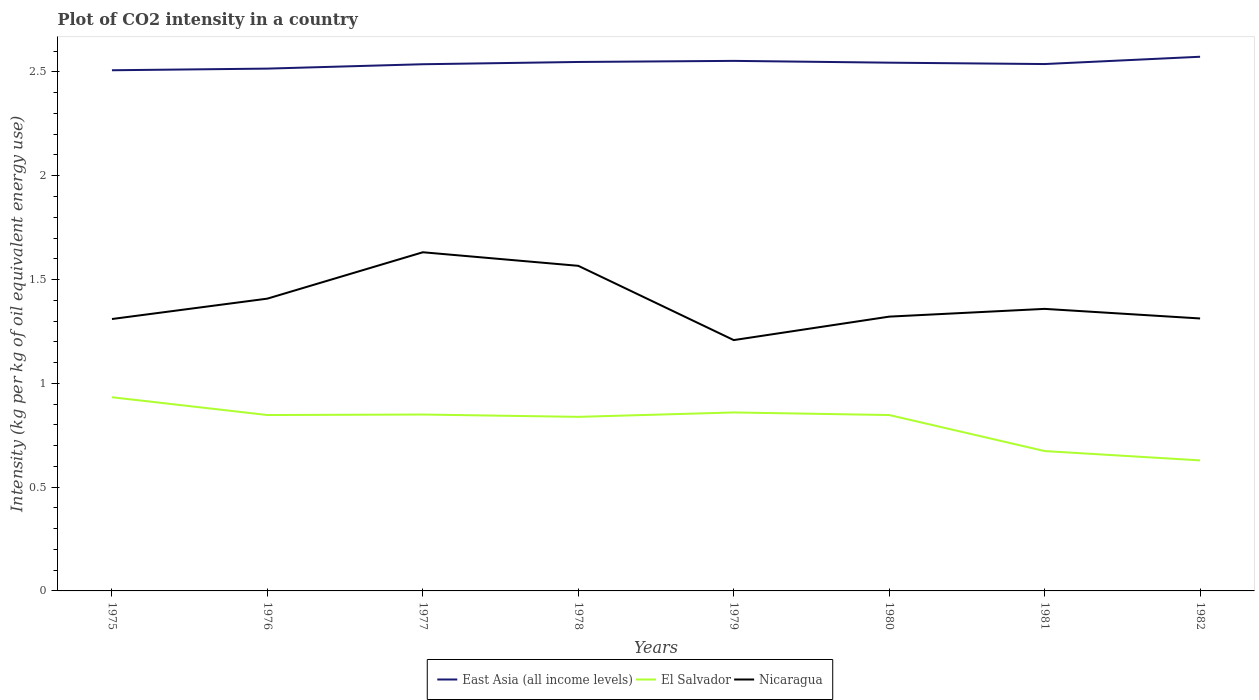How many different coloured lines are there?
Keep it short and to the point. 3. Does the line corresponding to El Salvador intersect with the line corresponding to Nicaragua?
Make the answer very short. No. Is the number of lines equal to the number of legend labels?
Your answer should be very brief. Yes. Across all years, what is the maximum CO2 intensity in in El Salvador?
Your answer should be compact. 0.63. In which year was the CO2 intensity in in Nicaragua maximum?
Provide a short and direct response. 1979. What is the total CO2 intensity in in East Asia (all income levels) in the graph?
Provide a short and direct response. -0. What is the difference between the highest and the second highest CO2 intensity in in Nicaragua?
Make the answer very short. 0.42. Is the CO2 intensity in in Nicaragua strictly greater than the CO2 intensity in in East Asia (all income levels) over the years?
Your answer should be compact. Yes. What is the difference between two consecutive major ticks on the Y-axis?
Offer a terse response. 0.5. Are the values on the major ticks of Y-axis written in scientific E-notation?
Your answer should be very brief. No. Does the graph contain any zero values?
Ensure brevity in your answer.  No. Does the graph contain grids?
Offer a terse response. No. Where does the legend appear in the graph?
Offer a very short reply. Bottom center. How many legend labels are there?
Ensure brevity in your answer.  3. How are the legend labels stacked?
Make the answer very short. Horizontal. What is the title of the graph?
Offer a terse response. Plot of CO2 intensity in a country. What is the label or title of the Y-axis?
Offer a very short reply. Intensity (kg per kg of oil equivalent energy use). What is the Intensity (kg per kg of oil equivalent energy use) of East Asia (all income levels) in 1975?
Provide a short and direct response. 2.51. What is the Intensity (kg per kg of oil equivalent energy use) in El Salvador in 1975?
Ensure brevity in your answer.  0.93. What is the Intensity (kg per kg of oil equivalent energy use) of Nicaragua in 1975?
Offer a very short reply. 1.31. What is the Intensity (kg per kg of oil equivalent energy use) of East Asia (all income levels) in 1976?
Keep it short and to the point. 2.52. What is the Intensity (kg per kg of oil equivalent energy use) in El Salvador in 1976?
Your answer should be very brief. 0.85. What is the Intensity (kg per kg of oil equivalent energy use) in Nicaragua in 1976?
Provide a short and direct response. 1.41. What is the Intensity (kg per kg of oil equivalent energy use) of East Asia (all income levels) in 1977?
Your answer should be compact. 2.54. What is the Intensity (kg per kg of oil equivalent energy use) in El Salvador in 1977?
Your response must be concise. 0.85. What is the Intensity (kg per kg of oil equivalent energy use) in Nicaragua in 1977?
Your response must be concise. 1.63. What is the Intensity (kg per kg of oil equivalent energy use) in East Asia (all income levels) in 1978?
Give a very brief answer. 2.55. What is the Intensity (kg per kg of oil equivalent energy use) in El Salvador in 1978?
Your answer should be compact. 0.84. What is the Intensity (kg per kg of oil equivalent energy use) of Nicaragua in 1978?
Provide a succinct answer. 1.57. What is the Intensity (kg per kg of oil equivalent energy use) in East Asia (all income levels) in 1979?
Your response must be concise. 2.55. What is the Intensity (kg per kg of oil equivalent energy use) of El Salvador in 1979?
Keep it short and to the point. 0.86. What is the Intensity (kg per kg of oil equivalent energy use) in Nicaragua in 1979?
Offer a very short reply. 1.21. What is the Intensity (kg per kg of oil equivalent energy use) of East Asia (all income levels) in 1980?
Provide a short and direct response. 2.54. What is the Intensity (kg per kg of oil equivalent energy use) of El Salvador in 1980?
Give a very brief answer. 0.85. What is the Intensity (kg per kg of oil equivalent energy use) in Nicaragua in 1980?
Offer a terse response. 1.32. What is the Intensity (kg per kg of oil equivalent energy use) in East Asia (all income levels) in 1981?
Provide a short and direct response. 2.54. What is the Intensity (kg per kg of oil equivalent energy use) of El Salvador in 1981?
Your answer should be compact. 0.67. What is the Intensity (kg per kg of oil equivalent energy use) in Nicaragua in 1981?
Give a very brief answer. 1.36. What is the Intensity (kg per kg of oil equivalent energy use) in East Asia (all income levels) in 1982?
Your answer should be compact. 2.57. What is the Intensity (kg per kg of oil equivalent energy use) in El Salvador in 1982?
Your response must be concise. 0.63. What is the Intensity (kg per kg of oil equivalent energy use) of Nicaragua in 1982?
Make the answer very short. 1.31. Across all years, what is the maximum Intensity (kg per kg of oil equivalent energy use) in East Asia (all income levels)?
Ensure brevity in your answer.  2.57. Across all years, what is the maximum Intensity (kg per kg of oil equivalent energy use) in El Salvador?
Your answer should be very brief. 0.93. Across all years, what is the maximum Intensity (kg per kg of oil equivalent energy use) in Nicaragua?
Provide a succinct answer. 1.63. Across all years, what is the minimum Intensity (kg per kg of oil equivalent energy use) in East Asia (all income levels)?
Your answer should be very brief. 2.51. Across all years, what is the minimum Intensity (kg per kg of oil equivalent energy use) of El Salvador?
Offer a very short reply. 0.63. Across all years, what is the minimum Intensity (kg per kg of oil equivalent energy use) of Nicaragua?
Offer a very short reply. 1.21. What is the total Intensity (kg per kg of oil equivalent energy use) in East Asia (all income levels) in the graph?
Offer a very short reply. 20.32. What is the total Intensity (kg per kg of oil equivalent energy use) of El Salvador in the graph?
Offer a terse response. 6.48. What is the total Intensity (kg per kg of oil equivalent energy use) of Nicaragua in the graph?
Your answer should be compact. 11.12. What is the difference between the Intensity (kg per kg of oil equivalent energy use) in East Asia (all income levels) in 1975 and that in 1976?
Keep it short and to the point. -0.01. What is the difference between the Intensity (kg per kg of oil equivalent energy use) in El Salvador in 1975 and that in 1976?
Ensure brevity in your answer.  0.09. What is the difference between the Intensity (kg per kg of oil equivalent energy use) in Nicaragua in 1975 and that in 1976?
Provide a succinct answer. -0.1. What is the difference between the Intensity (kg per kg of oil equivalent energy use) of East Asia (all income levels) in 1975 and that in 1977?
Your answer should be very brief. -0.03. What is the difference between the Intensity (kg per kg of oil equivalent energy use) of El Salvador in 1975 and that in 1977?
Provide a succinct answer. 0.08. What is the difference between the Intensity (kg per kg of oil equivalent energy use) of Nicaragua in 1975 and that in 1977?
Give a very brief answer. -0.32. What is the difference between the Intensity (kg per kg of oil equivalent energy use) in East Asia (all income levels) in 1975 and that in 1978?
Make the answer very short. -0.04. What is the difference between the Intensity (kg per kg of oil equivalent energy use) in El Salvador in 1975 and that in 1978?
Provide a short and direct response. 0.09. What is the difference between the Intensity (kg per kg of oil equivalent energy use) of Nicaragua in 1975 and that in 1978?
Offer a very short reply. -0.26. What is the difference between the Intensity (kg per kg of oil equivalent energy use) of East Asia (all income levels) in 1975 and that in 1979?
Offer a very short reply. -0.05. What is the difference between the Intensity (kg per kg of oil equivalent energy use) in El Salvador in 1975 and that in 1979?
Offer a very short reply. 0.07. What is the difference between the Intensity (kg per kg of oil equivalent energy use) of Nicaragua in 1975 and that in 1979?
Keep it short and to the point. 0.1. What is the difference between the Intensity (kg per kg of oil equivalent energy use) in East Asia (all income levels) in 1975 and that in 1980?
Ensure brevity in your answer.  -0.04. What is the difference between the Intensity (kg per kg of oil equivalent energy use) in El Salvador in 1975 and that in 1980?
Provide a short and direct response. 0.09. What is the difference between the Intensity (kg per kg of oil equivalent energy use) of Nicaragua in 1975 and that in 1980?
Give a very brief answer. -0.01. What is the difference between the Intensity (kg per kg of oil equivalent energy use) of East Asia (all income levels) in 1975 and that in 1981?
Give a very brief answer. -0.03. What is the difference between the Intensity (kg per kg of oil equivalent energy use) of El Salvador in 1975 and that in 1981?
Provide a short and direct response. 0.26. What is the difference between the Intensity (kg per kg of oil equivalent energy use) in Nicaragua in 1975 and that in 1981?
Provide a succinct answer. -0.05. What is the difference between the Intensity (kg per kg of oil equivalent energy use) of East Asia (all income levels) in 1975 and that in 1982?
Offer a terse response. -0.07. What is the difference between the Intensity (kg per kg of oil equivalent energy use) in El Salvador in 1975 and that in 1982?
Your answer should be compact. 0.3. What is the difference between the Intensity (kg per kg of oil equivalent energy use) in Nicaragua in 1975 and that in 1982?
Make the answer very short. -0. What is the difference between the Intensity (kg per kg of oil equivalent energy use) of East Asia (all income levels) in 1976 and that in 1977?
Provide a short and direct response. -0.02. What is the difference between the Intensity (kg per kg of oil equivalent energy use) of El Salvador in 1976 and that in 1977?
Provide a short and direct response. -0. What is the difference between the Intensity (kg per kg of oil equivalent energy use) of Nicaragua in 1976 and that in 1977?
Your response must be concise. -0.22. What is the difference between the Intensity (kg per kg of oil equivalent energy use) in East Asia (all income levels) in 1976 and that in 1978?
Provide a succinct answer. -0.03. What is the difference between the Intensity (kg per kg of oil equivalent energy use) in El Salvador in 1976 and that in 1978?
Offer a very short reply. 0.01. What is the difference between the Intensity (kg per kg of oil equivalent energy use) in Nicaragua in 1976 and that in 1978?
Your answer should be compact. -0.16. What is the difference between the Intensity (kg per kg of oil equivalent energy use) in East Asia (all income levels) in 1976 and that in 1979?
Offer a very short reply. -0.04. What is the difference between the Intensity (kg per kg of oil equivalent energy use) of El Salvador in 1976 and that in 1979?
Ensure brevity in your answer.  -0.01. What is the difference between the Intensity (kg per kg of oil equivalent energy use) in Nicaragua in 1976 and that in 1979?
Give a very brief answer. 0.2. What is the difference between the Intensity (kg per kg of oil equivalent energy use) of East Asia (all income levels) in 1976 and that in 1980?
Keep it short and to the point. -0.03. What is the difference between the Intensity (kg per kg of oil equivalent energy use) of Nicaragua in 1976 and that in 1980?
Provide a succinct answer. 0.09. What is the difference between the Intensity (kg per kg of oil equivalent energy use) in East Asia (all income levels) in 1976 and that in 1981?
Make the answer very short. -0.02. What is the difference between the Intensity (kg per kg of oil equivalent energy use) in El Salvador in 1976 and that in 1981?
Ensure brevity in your answer.  0.17. What is the difference between the Intensity (kg per kg of oil equivalent energy use) in Nicaragua in 1976 and that in 1981?
Ensure brevity in your answer.  0.05. What is the difference between the Intensity (kg per kg of oil equivalent energy use) of East Asia (all income levels) in 1976 and that in 1982?
Give a very brief answer. -0.06. What is the difference between the Intensity (kg per kg of oil equivalent energy use) in El Salvador in 1976 and that in 1982?
Ensure brevity in your answer.  0.22. What is the difference between the Intensity (kg per kg of oil equivalent energy use) in Nicaragua in 1976 and that in 1982?
Offer a terse response. 0.1. What is the difference between the Intensity (kg per kg of oil equivalent energy use) in East Asia (all income levels) in 1977 and that in 1978?
Your response must be concise. -0.01. What is the difference between the Intensity (kg per kg of oil equivalent energy use) in El Salvador in 1977 and that in 1978?
Provide a short and direct response. 0.01. What is the difference between the Intensity (kg per kg of oil equivalent energy use) in Nicaragua in 1977 and that in 1978?
Provide a short and direct response. 0.07. What is the difference between the Intensity (kg per kg of oil equivalent energy use) of East Asia (all income levels) in 1977 and that in 1979?
Keep it short and to the point. -0.02. What is the difference between the Intensity (kg per kg of oil equivalent energy use) of El Salvador in 1977 and that in 1979?
Provide a short and direct response. -0.01. What is the difference between the Intensity (kg per kg of oil equivalent energy use) in Nicaragua in 1977 and that in 1979?
Your response must be concise. 0.42. What is the difference between the Intensity (kg per kg of oil equivalent energy use) in East Asia (all income levels) in 1977 and that in 1980?
Ensure brevity in your answer.  -0.01. What is the difference between the Intensity (kg per kg of oil equivalent energy use) of El Salvador in 1977 and that in 1980?
Give a very brief answer. 0. What is the difference between the Intensity (kg per kg of oil equivalent energy use) in Nicaragua in 1977 and that in 1980?
Keep it short and to the point. 0.31. What is the difference between the Intensity (kg per kg of oil equivalent energy use) of East Asia (all income levels) in 1977 and that in 1981?
Offer a very short reply. -0. What is the difference between the Intensity (kg per kg of oil equivalent energy use) of El Salvador in 1977 and that in 1981?
Offer a very short reply. 0.18. What is the difference between the Intensity (kg per kg of oil equivalent energy use) in Nicaragua in 1977 and that in 1981?
Provide a succinct answer. 0.27. What is the difference between the Intensity (kg per kg of oil equivalent energy use) of East Asia (all income levels) in 1977 and that in 1982?
Give a very brief answer. -0.04. What is the difference between the Intensity (kg per kg of oil equivalent energy use) of El Salvador in 1977 and that in 1982?
Your response must be concise. 0.22. What is the difference between the Intensity (kg per kg of oil equivalent energy use) in Nicaragua in 1977 and that in 1982?
Your answer should be compact. 0.32. What is the difference between the Intensity (kg per kg of oil equivalent energy use) in East Asia (all income levels) in 1978 and that in 1979?
Offer a terse response. -0.01. What is the difference between the Intensity (kg per kg of oil equivalent energy use) of El Salvador in 1978 and that in 1979?
Make the answer very short. -0.02. What is the difference between the Intensity (kg per kg of oil equivalent energy use) of Nicaragua in 1978 and that in 1979?
Your answer should be compact. 0.36. What is the difference between the Intensity (kg per kg of oil equivalent energy use) in East Asia (all income levels) in 1978 and that in 1980?
Offer a terse response. 0. What is the difference between the Intensity (kg per kg of oil equivalent energy use) in El Salvador in 1978 and that in 1980?
Your answer should be very brief. -0.01. What is the difference between the Intensity (kg per kg of oil equivalent energy use) in Nicaragua in 1978 and that in 1980?
Your response must be concise. 0.24. What is the difference between the Intensity (kg per kg of oil equivalent energy use) in El Salvador in 1978 and that in 1981?
Provide a short and direct response. 0.16. What is the difference between the Intensity (kg per kg of oil equivalent energy use) of Nicaragua in 1978 and that in 1981?
Provide a succinct answer. 0.21. What is the difference between the Intensity (kg per kg of oil equivalent energy use) in East Asia (all income levels) in 1978 and that in 1982?
Provide a short and direct response. -0.03. What is the difference between the Intensity (kg per kg of oil equivalent energy use) in El Salvador in 1978 and that in 1982?
Provide a short and direct response. 0.21. What is the difference between the Intensity (kg per kg of oil equivalent energy use) of Nicaragua in 1978 and that in 1982?
Your answer should be very brief. 0.25. What is the difference between the Intensity (kg per kg of oil equivalent energy use) in East Asia (all income levels) in 1979 and that in 1980?
Offer a terse response. 0.01. What is the difference between the Intensity (kg per kg of oil equivalent energy use) of El Salvador in 1979 and that in 1980?
Ensure brevity in your answer.  0.01. What is the difference between the Intensity (kg per kg of oil equivalent energy use) in Nicaragua in 1979 and that in 1980?
Your answer should be very brief. -0.11. What is the difference between the Intensity (kg per kg of oil equivalent energy use) of East Asia (all income levels) in 1979 and that in 1981?
Provide a short and direct response. 0.02. What is the difference between the Intensity (kg per kg of oil equivalent energy use) in El Salvador in 1979 and that in 1981?
Make the answer very short. 0.19. What is the difference between the Intensity (kg per kg of oil equivalent energy use) of Nicaragua in 1979 and that in 1981?
Your answer should be very brief. -0.15. What is the difference between the Intensity (kg per kg of oil equivalent energy use) of East Asia (all income levels) in 1979 and that in 1982?
Keep it short and to the point. -0.02. What is the difference between the Intensity (kg per kg of oil equivalent energy use) in El Salvador in 1979 and that in 1982?
Your answer should be very brief. 0.23. What is the difference between the Intensity (kg per kg of oil equivalent energy use) in Nicaragua in 1979 and that in 1982?
Offer a terse response. -0.1. What is the difference between the Intensity (kg per kg of oil equivalent energy use) of East Asia (all income levels) in 1980 and that in 1981?
Ensure brevity in your answer.  0.01. What is the difference between the Intensity (kg per kg of oil equivalent energy use) of El Salvador in 1980 and that in 1981?
Your answer should be very brief. 0.17. What is the difference between the Intensity (kg per kg of oil equivalent energy use) of Nicaragua in 1980 and that in 1981?
Give a very brief answer. -0.04. What is the difference between the Intensity (kg per kg of oil equivalent energy use) in East Asia (all income levels) in 1980 and that in 1982?
Provide a succinct answer. -0.03. What is the difference between the Intensity (kg per kg of oil equivalent energy use) in El Salvador in 1980 and that in 1982?
Provide a succinct answer. 0.22. What is the difference between the Intensity (kg per kg of oil equivalent energy use) of Nicaragua in 1980 and that in 1982?
Your response must be concise. 0.01. What is the difference between the Intensity (kg per kg of oil equivalent energy use) of East Asia (all income levels) in 1981 and that in 1982?
Ensure brevity in your answer.  -0.04. What is the difference between the Intensity (kg per kg of oil equivalent energy use) in El Salvador in 1981 and that in 1982?
Your response must be concise. 0.04. What is the difference between the Intensity (kg per kg of oil equivalent energy use) of Nicaragua in 1981 and that in 1982?
Provide a succinct answer. 0.05. What is the difference between the Intensity (kg per kg of oil equivalent energy use) in East Asia (all income levels) in 1975 and the Intensity (kg per kg of oil equivalent energy use) in El Salvador in 1976?
Your answer should be very brief. 1.66. What is the difference between the Intensity (kg per kg of oil equivalent energy use) of East Asia (all income levels) in 1975 and the Intensity (kg per kg of oil equivalent energy use) of Nicaragua in 1976?
Your answer should be very brief. 1.1. What is the difference between the Intensity (kg per kg of oil equivalent energy use) of El Salvador in 1975 and the Intensity (kg per kg of oil equivalent energy use) of Nicaragua in 1976?
Make the answer very short. -0.48. What is the difference between the Intensity (kg per kg of oil equivalent energy use) of East Asia (all income levels) in 1975 and the Intensity (kg per kg of oil equivalent energy use) of El Salvador in 1977?
Keep it short and to the point. 1.66. What is the difference between the Intensity (kg per kg of oil equivalent energy use) in East Asia (all income levels) in 1975 and the Intensity (kg per kg of oil equivalent energy use) in Nicaragua in 1977?
Provide a succinct answer. 0.88. What is the difference between the Intensity (kg per kg of oil equivalent energy use) of El Salvador in 1975 and the Intensity (kg per kg of oil equivalent energy use) of Nicaragua in 1977?
Keep it short and to the point. -0.7. What is the difference between the Intensity (kg per kg of oil equivalent energy use) in East Asia (all income levels) in 1975 and the Intensity (kg per kg of oil equivalent energy use) in El Salvador in 1978?
Your answer should be compact. 1.67. What is the difference between the Intensity (kg per kg of oil equivalent energy use) in East Asia (all income levels) in 1975 and the Intensity (kg per kg of oil equivalent energy use) in Nicaragua in 1978?
Your answer should be very brief. 0.94. What is the difference between the Intensity (kg per kg of oil equivalent energy use) in El Salvador in 1975 and the Intensity (kg per kg of oil equivalent energy use) in Nicaragua in 1978?
Your answer should be very brief. -0.63. What is the difference between the Intensity (kg per kg of oil equivalent energy use) in East Asia (all income levels) in 1975 and the Intensity (kg per kg of oil equivalent energy use) in El Salvador in 1979?
Make the answer very short. 1.65. What is the difference between the Intensity (kg per kg of oil equivalent energy use) in East Asia (all income levels) in 1975 and the Intensity (kg per kg of oil equivalent energy use) in Nicaragua in 1979?
Provide a short and direct response. 1.3. What is the difference between the Intensity (kg per kg of oil equivalent energy use) in El Salvador in 1975 and the Intensity (kg per kg of oil equivalent energy use) in Nicaragua in 1979?
Your answer should be compact. -0.28. What is the difference between the Intensity (kg per kg of oil equivalent energy use) in East Asia (all income levels) in 1975 and the Intensity (kg per kg of oil equivalent energy use) in El Salvador in 1980?
Offer a very short reply. 1.66. What is the difference between the Intensity (kg per kg of oil equivalent energy use) of East Asia (all income levels) in 1975 and the Intensity (kg per kg of oil equivalent energy use) of Nicaragua in 1980?
Keep it short and to the point. 1.19. What is the difference between the Intensity (kg per kg of oil equivalent energy use) in El Salvador in 1975 and the Intensity (kg per kg of oil equivalent energy use) in Nicaragua in 1980?
Offer a very short reply. -0.39. What is the difference between the Intensity (kg per kg of oil equivalent energy use) of East Asia (all income levels) in 1975 and the Intensity (kg per kg of oil equivalent energy use) of El Salvador in 1981?
Give a very brief answer. 1.83. What is the difference between the Intensity (kg per kg of oil equivalent energy use) in East Asia (all income levels) in 1975 and the Intensity (kg per kg of oil equivalent energy use) in Nicaragua in 1981?
Offer a terse response. 1.15. What is the difference between the Intensity (kg per kg of oil equivalent energy use) in El Salvador in 1975 and the Intensity (kg per kg of oil equivalent energy use) in Nicaragua in 1981?
Offer a very short reply. -0.43. What is the difference between the Intensity (kg per kg of oil equivalent energy use) of East Asia (all income levels) in 1975 and the Intensity (kg per kg of oil equivalent energy use) of El Salvador in 1982?
Your answer should be very brief. 1.88. What is the difference between the Intensity (kg per kg of oil equivalent energy use) in East Asia (all income levels) in 1975 and the Intensity (kg per kg of oil equivalent energy use) in Nicaragua in 1982?
Your answer should be very brief. 1.2. What is the difference between the Intensity (kg per kg of oil equivalent energy use) of El Salvador in 1975 and the Intensity (kg per kg of oil equivalent energy use) of Nicaragua in 1982?
Offer a terse response. -0.38. What is the difference between the Intensity (kg per kg of oil equivalent energy use) of East Asia (all income levels) in 1976 and the Intensity (kg per kg of oil equivalent energy use) of El Salvador in 1977?
Offer a very short reply. 1.67. What is the difference between the Intensity (kg per kg of oil equivalent energy use) of East Asia (all income levels) in 1976 and the Intensity (kg per kg of oil equivalent energy use) of Nicaragua in 1977?
Your answer should be compact. 0.88. What is the difference between the Intensity (kg per kg of oil equivalent energy use) of El Salvador in 1976 and the Intensity (kg per kg of oil equivalent energy use) of Nicaragua in 1977?
Keep it short and to the point. -0.78. What is the difference between the Intensity (kg per kg of oil equivalent energy use) in East Asia (all income levels) in 1976 and the Intensity (kg per kg of oil equivalent energy use) in El Salvador in 1978?
Keep it short and to the point. 1.68. What is the difference between the Intensity (kg per kg of oil equivalent energy use) of El Salvador in 1976 and the Intensity (kg per kg of oil equivalent energy use) of Nicaragua in 1978?
Make the answer very short. -0.72. What is the difference between the Intensity (kg per kg of oil equivalent energy use) of East Asia (all income levels) in 1976 and the Intensity (kg per kg of oil equivalent energy use) of El Salvador in 1979?
Your response must be concise. 1.66. What is the difference between the Intensity (kg per kg of oil equivalent energy use) in East Asia (all income levels) in 1976 and the Intensity (kg per kg of oil equivalent energy use) in Nicaragua in 1979?
Provide a succinct answer. 1.31. What is the difference between the Intensity (kg per kg of oil equivalent energy use) of El Salvador in 1976 and the Intensity (kg per kg of oil equivalent energy use) of Nicaragua in 1979?
Offer a terse response. -0.36. What is the difference between the Intensity (kg per kg of oil equivalent energy use) in East Asia (all income levels) in 1976 and the Intensity (kg per kg of oil equivalent energy use) in El Salvador in 1980?
Offer a terse response. 1.67. What is the difference between the Intensity (kg per kg of oil equivalent energy use) of East Asia (all income levels) in 1976 and the Intensity (kg per kg of oil equivalent energy use) of Nicaragua in 1980?
Your answer should be compact. 1.19. What is the difference between the Intensity (kg per kg of oil equivalent energy use) of El Salvador in 1976 and the Intensity (kg per kg of oil equivalent energy use) of Nicaragua in 1980?
Make the answer very short. -0.47. What is the difference between the Intensity (kg per kg of oil equivalent energy use) of East Asia (all income levels) in 1976 and the Intensity (kg per kg of oil equivalent energy use) of El Salvador in 1981?
Keep it short and to the point. 1.84. What is the difference between the Intensity (kg per kg of oil equivalent energy use) in East Asia (all income levels) in 1976 and the Intensity (kg per kg of oil equivalent energy use) in Nicaragua in 1981?
Your answer should be very brief. 1.16. What is the difference between the Intensity (kg per kg of oil equivalent energy use) in El Salvador in 1976 and the Intensity (kg per kg of oil equivalent energy use) in Nicaragua in 1981?
Offer a terse response. -0.51. What is the difference between the Intensity (kg per kg of oil equivalent energy use) of East Asia (all income levels) in 1976 and the Intensity (kg per kg of oil equivalent energy use) of El Salvador in 1982?
Ensure brevity in your answer.  1.89. What is the difference between the Intensity (kg per kg of oil equivalent energy use) of East Asia (all income levels) in 1976 and the Intensity (kg per kg of oil equivalent energy use) of Nicaragua in 1982?
Provide a short and direct response. 1.2. What is the difference between the Intensity (kg per kg of oil equivalent energy use) in El Salvador in 1976 and the Intensity (kg per kg of oil equivalent energy use) in Nicaragua in 1982?
Give a very brief answer. -0.47. What is the difference between the Intensity (kg per kg of oil equivalent energy use) in East Asia (all income levels) in 1977 and the Intensity (kg per kg of oil equivalent energy use) in El Salvador in 1978?
Ensure brevity in your answer.  1.7. What is the difference between the Intensity (kg per kg of oil equivalent energy use) in East Asia (all income levels) in 1977 and the Intensity (kg per kg of oil equivalent energy use) in Nicaragua in 1978?
Ensure brevity in your answer.  0.97. What is the difference between the Intensity (kg per kg of oil equivalent energy use) in El Salvador in 1977 and the Intensity (kg per kg of oil equivalent energy use) in Nicaragua in 1978?
Provide a succinct answer. -0.72. What is the difference between the Intensity (kg per kg of oil equivalent energy use) of East Asia (all income levels) in 1977 and the Intensity (kg per kg of oil equivalent energy use) of El Salvador in 1979?
Ensure brevity in your answer.  1.68. What is the difference between the Intensity (kg per kg of oil equivalent energy use) of East Asia (all income levels) in 1977 and the Intensity (kg per kg of oil equivalent energy use) of Nicaragua in 1979?
Offer a very short reply. 1.33. What is the difference between the Intensity (kg per kg of oil equivalent energy use) of El Salvador in 1977 and the Intensity (kg per kg of oil equivalent energy use) of Nicaragua in 1979?
Your answer should be compact. -0.36. What is the difference between the Intensity (kg per kg of oil equivalent energy use) of East Asia (all income levels) in 1977 and the Intensity (kg per kg of oil equivalent energy use) of El Salvador in 1980?
Offer a terse response. 1.69. What is the difference between the Intensity (kg per kg of oil equivalent energy use) in East Asia (all income levels) in 1977 and the Intensity (kg per kg of oil equivalent energy use) in Nicaragua in 1980?
Give a very brief answer. 1.22. What is the difference between the Intensity (kg per kg of oil equivalent energy use) of El Salvador in 1977 and the Intensity (kg per kg of oil equivalent energy use) of Nicaragua in 1980?
Provide a succinct answer. -0.47. What is the difference between the Intensity (kg per kg of oil equivalent energy use) of East Asia (all income levels) in 1977 and the Intensity (kg per kg of oil equivalent energy use) of El Salvador in 1981?
Keep it short and to the point. 1.86. What is the difference between the Intensity (kg per kg of oil equivalent energy use) of East Asia (all income levels) in 1977 and the Intensity (kg per kg of oil equivalent energy use) of Nicaragua in 1981?
Keep it short and to the point. 1.18. What is the difference between the Intensity (kg per kg of oil equivalent energy use) in El Salvador in 1977 and the Intensity (kg per kg of oil equivalent energy use) in Nicaragua in 1981?
Provide a short and direct response. -0.51. What is the difference between the Intensity (kg per kg of oil equivalent energy use) in East Asia (all income levels) in 1977 and the Intensity (kg per kg of oil equivalent energy use) in El Salvador in 1982?
Provide a short and direct response. 1.91. What is the difference between the Intensity (kg per kg of oil equivalent energy use) in East Asia (all income levels) in 1977 and the Intensity (kg per kg of oil equivalent energy use) in Nicaragua in 1982?
Give a very brief answer. 1.22. What is the difference between the Intensity (kg per kg of oil equivalent energy use) in El Salvador in 1977 and the Intensity (kg per kg of oil equivalent energy use) in Nicaragua in 1982?
Offer a terse response. -0.46. What is the difference between the Intensity (kg per kg of oil equivalent energy use) in East Asia (all income levels) in 1978 and the Intensity (kg per kg of oil equivalent energy use) in El Salvador in 1979?
Give a very brief answer. 1.69. What is the difference between the Intensity (kg per kg of oil equivalent energy use) in East Asia (all income levels) in 1978 and the Intensity (kg per kg of oil equivalent energy use) in Nicaragua in 1979?
Keep it short and to the point. 1.34. What is the difference between the Intensity (kg per kg of oil equivalent energy use) in El Salvador in 1978 and the Intensity (kg per kg of oil equivalent energy use) in Nicaragua in 1979?
Provide a short and direct response. -0.37. What is the difference between the Intensity (kg per kg of oil equivalent energy use) in East Asia (all income levels) in 1978 and the Intensity (kg per kg of oil equivalent energy use) in El Salvador in 1980?
Your answer should be very brief. 1.7. What is the difference between the Intensity (kg per kg of oil equivalent energy use) in East Asia (all income levels) in 1978 and the Intensity (kg per kg of oil equivalent energy use) in Nicaragua in 1980?
Make the answer very short. 1.23. What is the difference between the Intensity (kg per kg of oil equivalent energy use) of El Salvador in 1978 and the Intensity (kg per kg of oil equivalent energy use) of Nicaragua in 1980?
Your answer should be compact. -0.48. What is the difference between the Intensity (kg per kg of oil equivalent energy use) in East Asia (all income levels) in 1978 and the Intensity (kg per kg of oil equivalent energy use) in El Salvador in 1981?
Ensure brevity in your answer.  1.87. What is the difference between the Intensity (kg per kg of oil equivalent energy use) in East Asia (all income levels) in 1978 and the Intensity (kg per kg of oil equivalent energy use) in Nicaragua in 1981?
Your answer should be compact. 1.19. What is the difference between the Intensity (kg per kg of oil equivalent energy use) of El Salvador in 1978 and the Intensity (kg per kg of oil equivalent energy use) of Nicaragua in 1981?
Give a very brief answer. -0.52. What is the difference between the Intensity (kg per kg of oil equivalent energy use) in East Asia (all income levels) in 1978 and the Intensity (kg per kg of oil equivalent energy use) in El Salvador in 1982?
Provide a short and direct response. 1.92. What is the difference between the Intensity (kg per kg of oil equivalent energy use) in East Asia (all income levels) in 1978 and the Intensity (kg per kg of oil equivalent energy use) in Nicaragua in 1982?
Your response must be concise. 1.24. What is the difference between the Intensity (kg per kg of oil equivalent energy use) of El Salvador in 1978 and the Intensity (kg per kg of oil equivalent energy use) of Nicaragua in 1982?
Make the answer very short. -0.47. What is the difference between the Intensity (kg per kg of oil equivalent energy use) in East Asia (all income levels) in 1979 and the Intensity (kg per kg of oil equivalent energy use) in El Salvador in 1980?
Your answer should be very brief. 1.71. What is the difference between the Intensity (kg per kg of oil equivalent energy use) in East Asia (all income levels) in 1979 and the Intensity (kg per kg of oil equivalent energy use) in Nicaragua in 1980?
Provide a short and direct response. 1.23. What is the difference between the Intensity (kg per kg of oil equivalent energy use) of El Salvador in 1979 and the Intensity (kg per kg of oil equivalent energy use) of Nicaragua in 1980?
Make the answer very short. -0.46. What is the difference between the Intensity (kg per kg of oil equivalent energy use) of East Asia (all income levels) in 1979 and the Intensity (kg per kg of oil equivalent energy use) of El Salvador in 1981?
Offer a terse response. 1.88. What is the difference between the Intensity (kg per kg of oil equivalent energy use) of East Asia (all income levels) in 1979 and the Intensity (kg per kg of oil equivalent energy use) of Nicaragua in 1981?
Provide a succinct answer. 1.19. What is the difference between the Intensity (kg per kg of oil equivalent energy use) in El Salvador in 1979 and the Intensity (kg per kg of oil equivalent energy use) in Nicaragua in 1981?
Provide a short and direct response. -0.5. What is the difference between the Intensity (kg per kg of oil equivalent energy use) of East Asia (all income levels) in 1979 and the Intensity (kg per kg of oil equivalent energy use) of El Salvador in 1982?
Your response must be concise. 1.92. What is the difference between the Intensity (kg per kg of oil equivalent energy use) in East Asia (all income levels) in 1979 and the Intensity (kg per kg of oil equivalent energy use) in Nicaragua in 1982?
Your response must be concise. 1.24. What is the difference between the Intensity (kg per kg of oil equivalent energy use) of El Salvador in 1979 and the Intensity (kg per kg of oil equivalent energy use) of Nicaragua in 1982?
Give a very brief answer. -0.45. What is the difference between the Intensity (kg per kg of oil equivalent energy use) in East Asia (all income levels) in 1980 and the Intensity (kg per kg of oil equivalent energy use) in El Salvador in 1981?
Your answer should be compact. 1.87. What is the difference between the Intensity (kg per kg of oil equivalent energy use) in East Asia (all income levels) in 1980 and the Intensity (kg per kg of oil equivalent energy use) in Nicaragua in 1981?
Make the answer very short. 1.19. What is the difference between the Intensity (kg per kg of oil equivalent energy use) of El Salvador in 1980 and the Intensity (kg per kg of oil equivalent energy use) of Nicaragua in 1981?
Your response must be concise. -0.51. What is the difference between the Intensity (kg per kg of oil equivalent energy use) of East Asia (all income levels) in 1980 and the Intensity (kg per kg of oil equivalent energy use) of El Salvador in 1982?
Offer a very short reply. 1.92. What is the difference between the Intensity (kg per kg of oil equivalent energy use) in East Asia (all income levels) in 1980 and the Intensity (kg per kg of oil equivalent energy use) in Nicaragua in 1982?
Ensure brevity in your answer.  1.23. What is the difference between the Intensity (kg per kg of oil equivalent energy use) of El Salvador in 1980 and the Intensity (kg per kg of oil equivalent energy use) of Nicaragua in 1982?
Keep it short and to the point. -0.47. What is the difference between the Intensity (kg per kg of oil equivalent energy use) in East Asia (all income levels) in 1981 and the Intensity (kg per kg of oil equivalent energy use) in El Salvador in 1982?
Offer a terse response. 1.91. What is the difference between the Intensity (kg per kg of oil equivalent energy use) of East Asia (all income levels) in 1981 and the Intensity (kg per kg of oil equivalent energy use) of Nicaragua in 1982?
Your answer should be compact. 1.23. What is the difference between the Intensity (kg per kg of oil equivalent energy use) of El Salvador in 1981 and the Intensity (kg per kg of oil equivalent energy use) of Nicaragua in 1982?
Make the answer very short. -0.64. What is the average Intensity (kg per kg of oil equivalent energy use) in East Asia (all income levels) per year?
Make the answer very short. 2.54. What is the average Intensity (kg per kg of oil equivalent energy use) in El Salvador per year?
Offer a very short reply. 0.81. What is the average Intensity (kg per kg of oil equivalent energy use) in Nicaragua per year?
Your answer should be very brief. 1.39. In the year 1975, what is the difference between the Intensity (kg per kg of oil equivalent energy use) of East Asia (all income levels) and Intensity (kg per kg of oil equivalent energy use) of El Salvador?
Make the answer very short. 1.58. In the year 1975, what is the difference between the Intensity (kg per kg of oil equivalent energy use) of East Asia (all income levels) and Intensity (kg per kg of oil equivalent energy use) of Nicaragua?
Keep it short and to the point. 1.2. In the year 1975, what is the difference between the Intensity (kg per kg of oil equivalent energy use) of El Salvador and Intensity (kg per kg of oil equivalent energy use) of Nicaragua?
Offer a very short reply. -0.38. In the year 1976, what is the difference between the Intensity (kg per kg of oil equivalent energy use) of East Asia (all income levels) and Intensity (kg per kg of oil equivalent energy use) of El Salvador?
Make the answer very short. 1.67. In the year 1976, what is the difference between the Intensity (kg per kg of oil equivalent energy use) of East Asia (all income levels) and Intensity (kg per kg of oil equivalent energy use) of Nicaragua?
Your response must be concise. 1.11. In the year 1976, what is the difference between the Intensity (kg per kg of oil equivalent energy use) of El Salvador and Intensity (kg per kg of oil equivalent energy use) of Nicaragua?
Keep it short and to the point. -0.56. In the year 1977, what is the difference between the Intensity (kg per kg of oil equivalent energy use) in East Asia (all income levels) and Intensity (kg per kg of oil equivalent energy use) in El Salvador?
Ensure brevity in your answer.  1.69. In the year 1977, what is the difference between the Intensity (kg per kg of oil equivalent energy use) of East Asia (all income levels) and Intensity (kg per kg of oil equivalent energy use) of Nicaragua?
Offer a terse response. 0.91. In the year 1977, what is the difference between the Intensity (kg per kg of oil equivalent energy use) of El Salvador and Intensity (kg per kg of oil equivalent energy use) of Nicaragua?
Your response must be concise. -0.78. In the year 1978, what is the difference between the Intensity (kg per kg of oil equivalent energy use) of East Asia (all income levels) and Intensity (kg per kg of oil equivalent energy use) of El Salvador?
Your answer should be compact. 1.71. In the year 1978, what is the difference between the Intensity (kg per kg of oil equivalent energy use) in East Asia (all income levels) and Intensity (kg per kg of oil equivalent energy use) in Nicaragua?
Your answer should be compact. 0.98. In the year 1978, what is the difference between the Intensity (kg per kg of oil equivalent energy use) in El Salvador and Intensity (kg per kg of oil equivalent energy use) in Nicaragua?
Your answer should be very brief. -0.73. In the year 1979, what is the difference between the Intensity (kg per kg of oil equivalent energy use) in East Asia (all income levels) and Intensity (kg per kg of oil equivalent energy use) in El Salvador?
Make the answer very short. 1.69. In the year 1979, what is the difference between the Intensity (kg per kg of oil equivalent energy use) of East Asia (all income levels) and Intensity (kg per kg of oil equivalent energy use) of Nicaragua?
Keep it short and to the point. 1.34. In the year 1979, what is the difference between the Intensity (kg per kg of oil equivalent energy use) of El Salvador and Intensity (kg per kg of oil equivalent energy use) of Nicaragua?
Your answer should be compact. -0.35. In the year 1980, what is the difference between the Intensity (kg per kg of oil equivalent energy use) in East Asia (all income levels) and Intensity (kg per kg of oil equivalent energy use) in El Salvador?
Ensure brevity in your answer.  1.7. In the year 1980, what is the difference between the Intensity (kg per kg of oil equivalent energy use) of East Asia (all income levels) and Intensity (kg per kg of oil equivalent energy use) of Nicaragua?
Keep it short and to the point. 1.22. In the year 1980, what is the difference between the Intensity (kg per kg of oil equivalent energy use) in El Salvador and Intensity (kg per kg of oil equivalent energy use) in Nicaragua?
Provide a short and direct response. -0.47. In the year 1981, what is the difference between the Intensity (kg per kg of oil equivalent energy use) in East Asia (all income levels) and Intensity (kg per kg of oil equivalent energy use) in El Salvador?
Keep it short and to the point. 1.86. In the year 1981, what is the difference between the Intensity (kg per kg of oil equivalent energy use) of East Asia (all income levels) and Intensity (kg per kg of oil equivalent energy use) of Nicaragua?
Your response must be concise. 1.18. In the year 1981, what is the difference between the Intensity (kg per kg of oil equivalent energy use) in El Salvador and Intensity (kg per kg of oil equivalent energy use) in Nicaragua?
Offer a very short reply. -0.69. In the year 1982, what is the difference between the Intensity (kg per kg of oil equivalent energy use) of East Asia (all income levels) and Intensity (kg per kg of oil equivalent energy use) of El Salvador?
Your response must be concise. 1.94. In the year 1982, what is the difference between the Intensity (kg per kg of oil equivalent energy use) in East Asia (all income levels) and Intensity (kg per kg of oil equivalent energy use) in Nicaragua?
Keep it short and to the point. 1.26. In the year 1982, what is the difference between the Intensity (kg per kg of oil equivalent energy use) of El Salvador and Intensity (kg per kg of oil equivalent energy use) of Nicaragua?
Offer a terse response. -0.68. What is the ratio of the Intensity (kg per kg of oil equivalent energy use) of East Asia (all income levels) in 1975 to that in 1976?
Your answer should be compact. 1. What is the ratio of the Intensity (kg per kg of oil equivalent energy use) in El Salvador in 1975 to that in 1976?
Provide a succinct answer. 1.1. What is the ratio of the Intensity (kg per kg of oil equivalent energy use) of Nicaragua in 1975 to that in 1976?
Offer a very short reply. 0.93. What is the ratio of the Intensity (kg per kg of oil equivalent energy use) in El Salvador in 1975 to that in 1977?
Ensure brevity in your answer.  1.1. What is the ratio of the Intensity (kg per kg of oil equivalent energy use) in Nicaragua in 1975 to that in 1977?
Ensure brevity in your answer.  0.8. What is the ratio of the Intensity (kg per kg of oil equivalent energy use) of East Asia (all income levels) in 1975 to that in 1978?
Keep it short and to the point. 0.98. What is the ratio of the Intensity (kg per kg of oil equivalent energy use) in El Salvador in 1975 to that in 1978?
Your response must be concise. 1.11. What is the ratio of the Intensity (kg per kg of oil equivalent energy use) in Nicaragua in 1975 to that in 1978?
Give a very brief answer. 0.84. What is the ratio of the Intensity (kg per kg of oil equivalent energy use) of East Asia (all income levels) in 1975 to that in 1979?
Your answer should be very brief. 0.98. What is the ratio of the Intensity (kg per kg of oil equivalent energy use) in El Salvador in 1975 to that in 1979?
Your answer should be compact. 1.09. What is the ratio of the Intensity (kg per kg of oil equivalent energy use) of Nicaragua in 1975 to that in 1979?
Provide a succinct answer. 1.08. What is the ratio of the Intensity (kg per kg of oil equivalent energy use) of East Asia (all income levels) in 1975 to that in 1980?
Provide a short and direct response. 0.99. What is the ratio of the Intensity (kg per kg of oil equivalent energy use) of El Salvador in 1975 to that in 1980?
Your answer should be very brief. 1.1. What is the ratio of the Intensity (kg per kg of oil equivalent energy use) in Nicaragua in 1975 to that in 1980?
Offer a terse response. 0.99. What is the ratio of the Intensity (kg per kg of oil equivalent energy use) of El Salvador in 1975 to that in 1981?
Provide a short and direct response. 1.38. What is the ratio of the Intensity (kg per kg of oil equivalent energy use) of Nicaragua in 1975 to that in 1981?
Provide a short and direct response. 0.96. What is the ratio of the Intensity (kg per kg of oil equivalent energy use) in East Asia (all income levels) in 1975 to that in 1982?
Give a very brief answer. 0.97. What is the ratio of the Intensity (kg per kg of oil equivalent energy use) of El Salvador in 1975 to that in 1982?
Keep it short and to the point. 1.48. What is the ratio of the Intensity (kg per kg of oil equivalent energy use) of East Asia (all income levels) in 1976 to that in 1977?
Offer a terse response. 0.99. What is the ratio of the Intensity (kg per kg of oil equivalent energy use) of Nicaragua in 1976 to that in 1977?
Provide a short and direct response. 0.86. What is the ratio of the Intensity (kg per kg of oil equivalent energy use) of East Asia (all income levels) in 1976 to that in 1978?
Your response must be concise. 0.99. What is the ratio of the Intensity (kg per kg of oil equivalent energy use) of El Salvador in 1976 to that in 1978?
Ensure brevity in your answer.  1.01. What is the ratio of the Intensity (kg per kg of oil equivalent energy use) of Nicaragua in 1976 to that in 1978?
Give a very brief answer. 0.9. What is the ratio of the Intensity (kg per kg of oil equivalent energy use) in East Asia (all income levels) in 1976 to that in 1979?
Your response must be concise. 0.99. What is the ratio of the Intensity (kg per kg of oil equivalent energy use) in El Salvador in 1976 to that in 1979?
Give a very brief answer. 0.99. What is the ratio of the Intensity (kg per kg of oil equivalent energy use) of Nicaragua in 1976 to that in 1979?
Ensure brevity in your answer.  1.17. What is the ratio of the Intensity (kg per kg of oil equivalent energy use) in East Asia (all income levels) in 1976 to that in 1980?
Ensure brevity in your answer.  0.99. What is the ratio of the Intensity (kg per kg of oil equivalent energy use) in El Salvador in 1976 to that in 1980?
Ensure brevity in your answer.  1. What is the ratio of the Intensity (kg per kg of oil equivalent energy use) in Nicaragua in 1976 to that in 1980?
Give a very brief answer. 1.07. What is the ratio of the Intensity (kg per kg of oil equivalent energy use) in East Asia (all income levels) in 1976 to that in 1981?
Provide a short and direct response. 0.99. What is the ratio of the Intensity (kg per kg of oil equivalent energy use) in El Salvador in 1976 to that in 1981?
Offer a very short reply. 1.26. What is the ratio of the Intensity (kg per kg of oil equivalent energy use) of Nicaragua in 1976 to that in 1981?
Keep it short and to the point. 1.04. What is the ratio of the Intensity (kg per kg of oil equivalent energy use) in East Asia (all income levels) in 1976 to that in 1982?
Your response must be concise. 0.98. What is the ratio of the Intensity (kg per kg of oil equivalent energy use) in El Salvador in 1976 to that in 1982?
Ensure brevity in your answer.  1.35. What is the ratio of the Intensity (kg per kg of oil equivalent energy use) of Nicaragua in 1976 to that in 1982?
Give a very brief answer. 1.07. What is the ratio of the Intensity (kg per kg of oil equivalent energy use) in El Salvador in 1977 to that in 1978?
Your response must be concise. 1.01. What is the ratio of the Intensity (kg per kg of oil equivalent energy use) of Nicaragua in 1977 to that in 1978?
Make the answer very short. 1.04. What is the ratio of the Intensity (kg per kg of oil equivalent energy use) in El Salvador in 1977 to that in 1979?
Your response must be concise. 0.99. What is the ratio of the Intensity (kg per kg of oil equivalent energy use) of Nicaragua in 1977 to that in 1979?
Ensure brevity in your answer.  1.35. What is the ratio of the Intensity (kg per kg of oil equivalent energy use) in El Salvador in 1977 to that in 1980?
Offer a very short reply. 1. What is the ratio of the Intensity (kg per kg of oil equivalent energy use) of Nicaragua in 1977 to that in 1980?
Provide a succinct answer. 1.23. What is the ratio of the Intensity (kg per kg of oil equivalent energy use) in El Salvador in 1977 to that in 1981?
Make the answer very short. 1.26. What is the ratio of the Intensity (kg per kg of oil equivalent energy use) in Nicaragua in 1977 to that in 1981?
Make the answer very short. 1.2. What is the ratio of the Intensity (kg per kg of oil equivalent energy use) of El Salvador in 1977 to that in 1982?
Ensure brevity in your answer.  1.35. What is the ratio of the Intensity (kg per kg of oil equivalent energy use) of Nicaragua in 1977 to that in 1982?
Provide a succinct answer. 1.24. What is the ratio of the Intensity (kg per kg of oil equivalent energy use) of El Salvador in 1978 to that in 1979?
Ensure brevity in your answer.  0.98. What is the ratio of the Intensity (kg per kg of oil equivalent energy use) of Nicaragua in 1978 to that in 1979?
Your answer should be compact. 1.3. What is the ratio of the Intensity (kg per kg of oil equivalent energy use) of El Salvador in 1978 to that in 1980?
Your response must be concise. 0.99. What is the ratio of the Intensity (kg per kg of oil equivalent energy use) of Nicaragua in 1978 to that in 1980?
Give a very brief answer. 1.19. What is the ratio of the Intensity (kg per kg of oil equivalent energy use) in El Salvador in 1978 to that in 1981?
Make the answer very short. 1.24. What is the ratio of the Intensity (kg per kg of oil equivalent energy use) of Nicaragua in 1978 to that in 1981?
Provide a succinct answer. 1.15. What is the ratio of the Intensity (kg per kg of oil equivalent energy use) in East Asia (all income levels) in 1978 to that in 1982?
Provide a succinct answer. 0.99. What is the ratio of the Intensity (kg per kg of oil equivalent energy use) of El Salvador in 1978 to that in 1982?
Provide a short and direct response. 1.33. What is the ratio of the Intensity (kg per kg of oil equivalent energy use) in Nicaragua in 1978 to that in 1982?
Your answer should be compact. 1.19. What is the ratio of the Intensity (kg per kg of oil equivalent energy use) in East Asia (all income levels) in 1979 to that in 1980?
Keep it short and to the point. 1. What is the ratio of the Intensity (kg per kg of oil equivalent energy use) of El Salvador in 1979 to that in 1980?
Provide a succinct answer. 1.01. What is the ratio of the Intensity (kg per kg of oil equivalent energy use) in Nicaragua in 1979 to that in 1980?
Your response must be concise. 0.91. What is the ratio of the Intensity (kg per kg of oil equivalent energy use) in El Salvador in 1979 to that in 1981?
Your response must be concise. 1.28. What is the ratio of the Intensity (kg per kg of oil equivalent energy use) of Nicaragua in 1979 to that in 1981?
Offer a terse response. 0.89. What is the ratio of the Intensity (kg per kg of oil equivalent energy use) of El Salvador in 1979 to that in 1982?
Keep it short and to the point. 1.37. What is the ratio of the Intensity (kg per kg of oil equivalent energy use) in Nicaragua in 1979 to that in 1982?
Your response must be concise. 0.92. What is the ratio of the Intensity (kg per kg of oil equivalent energy use) in East Asia (all income levels) in 1980 to that in 1981?
Give a very brief answer. 1. What is the ratio of the Intensity (kg per kg of oil equivalent energy use) of El Salvador in 1980 to that in 1981?
Offer a very short reply. 1.26. What is the ratio of the Intensity (kg per kg of oil equivalent energy use) of Nicaragua in 1980 to that in 1981?
Make the answer very short. 0.97. What is the ratio of the Intensity (kg per kg of oil equivalent energy use) in East Asia (all income levels) in 1980 to that in 1982?
Your response must be concise. 0.99. What is the ratio of the Intensity (kg per kg of oil equivalent energy use) in El Salvador in 1980 to that in 1982?
Give a very brief answer. 1.35. What is the ratio of the Intensity (kg per kg of oil equivalent energy use) in Nicaragua in 1980 to that in 1982?
Ensure brevity in your answer.  1.01. What is the ratio of the Intensity (kg per kg of oil equivalent energy use) of East Asia (all income levels) in 1981 to that in 1982?
Your answer should be compact. 0.99. What is the ratio of the Intensity (kg per kg of oil equivalent energy use) of El Salvador in 1981 to that in 1982?
Keep it short and to the point. 1.07. What is the ratio of the Intensity (kg per kg of oil equivalent energy use) of Nicaragua in 1981 to that in 1982?
Ensure brevity in your answer.  1.04. What is the difference between the highest and the second highest Intensity (kg per kg of oil equivalent energy use) of East Asia (all income levels)?
Offer a terse response. 0.02. What is the difference between the highest and the second highest Intensity (kg per kg of oil equivalent energy use) of El Salvador?
Make the answer very short. 0.07. What is the difference between the highest and the second highest Intensity (kg per kg of oil equivalent energy use) of Nicaragua?
Your answer should be very brief. 0.07. What is the difference between the highest and the lowest Intensity (kg per kg of oil equivalent energy use) in East Asia (all income levels)?
Give a very brief answer. 0.07. What is the difference between the highest and the lowest Intensity (kg per kg of oil equivalent energy use) in El Salvador?
Provide a short and direct response. 0.3. What is the difference between the highest and the lowest Intensity (kg per kg of oil equivalent energy use) of Nicaragua?
Ensure brevity in your answer.  0.42. 